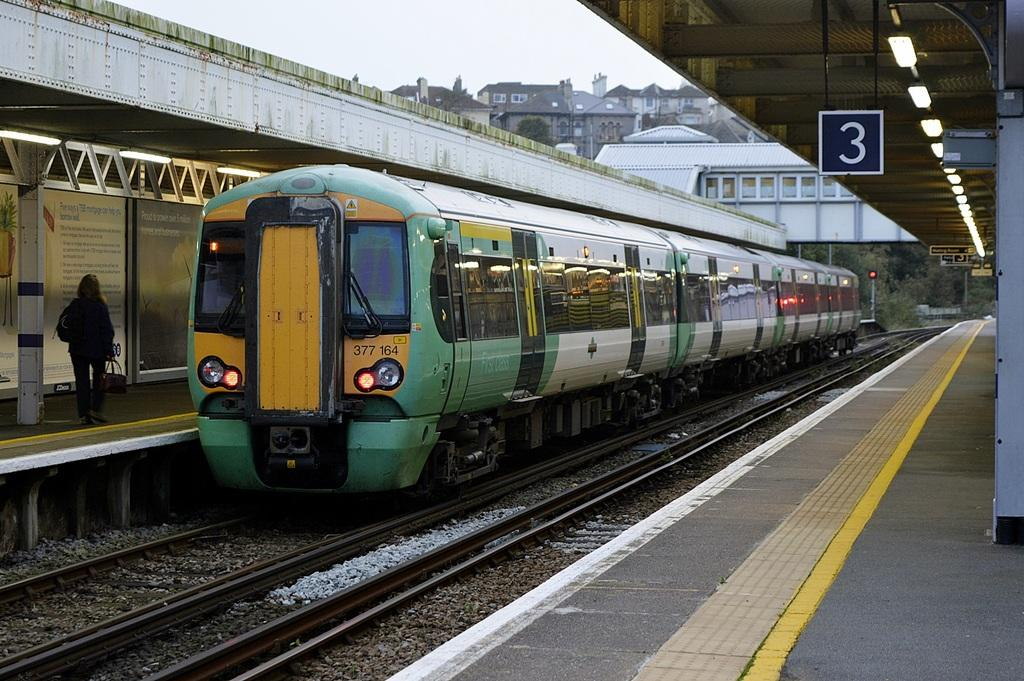Provide a one-sentence caption for the provided image. A train coming up to the number 3 line, a passenger is walking nearby. 